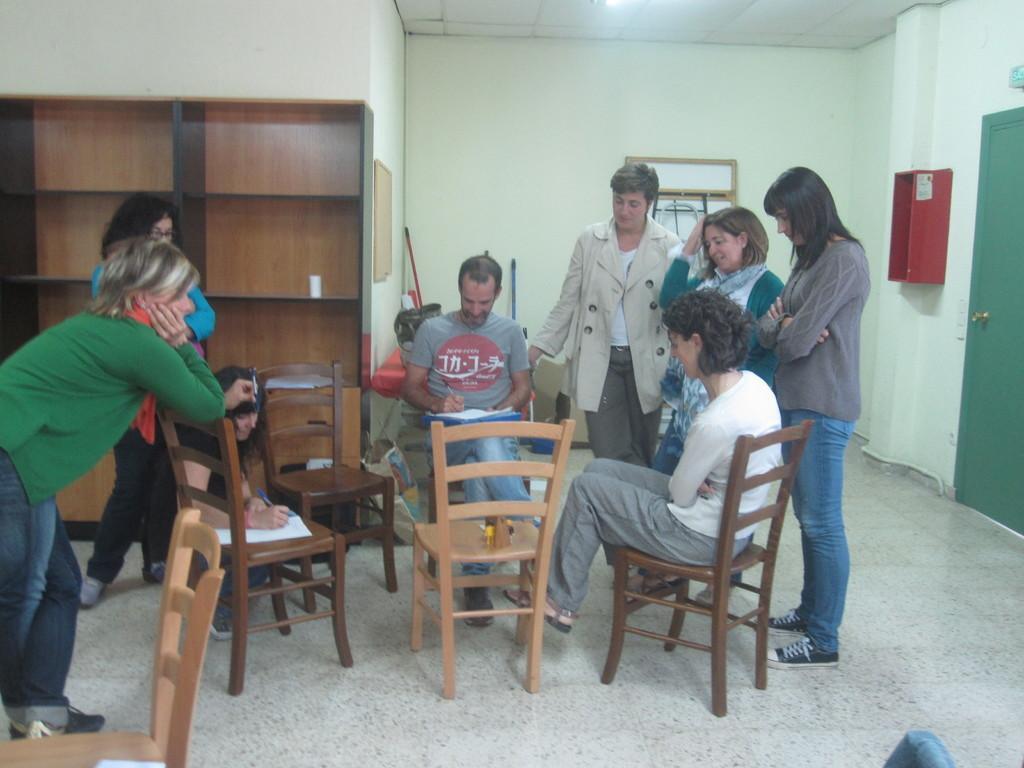How would you summarize this image in a sentence or two? There are two people sitting on the chairs and few people standing. This looks like a wooden rack. I can see an object, which is attached to the wall. This is a door with a door handle. In the background, I can see few objects, which are placed on the floor. This looks like a frame, which is attached to the wall. At the top of the image, I think this is the ceiling. 